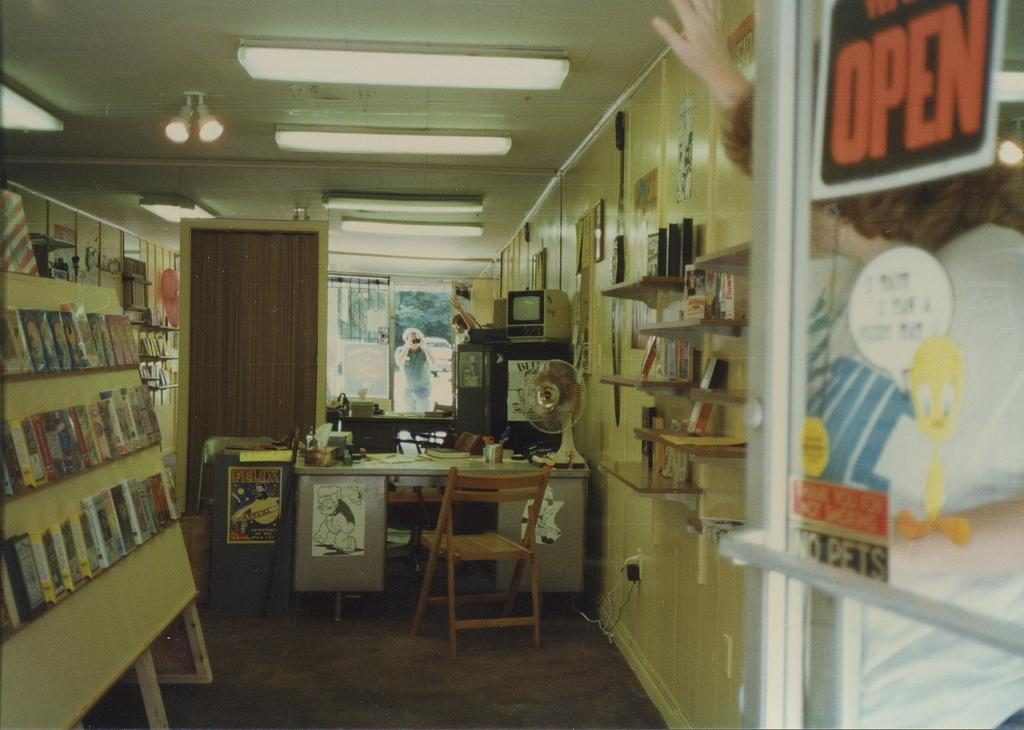<image>
Write a terse but informative summary of the picture. Novelty shop that the glass has a sign with black and orange OPEN lettering. 